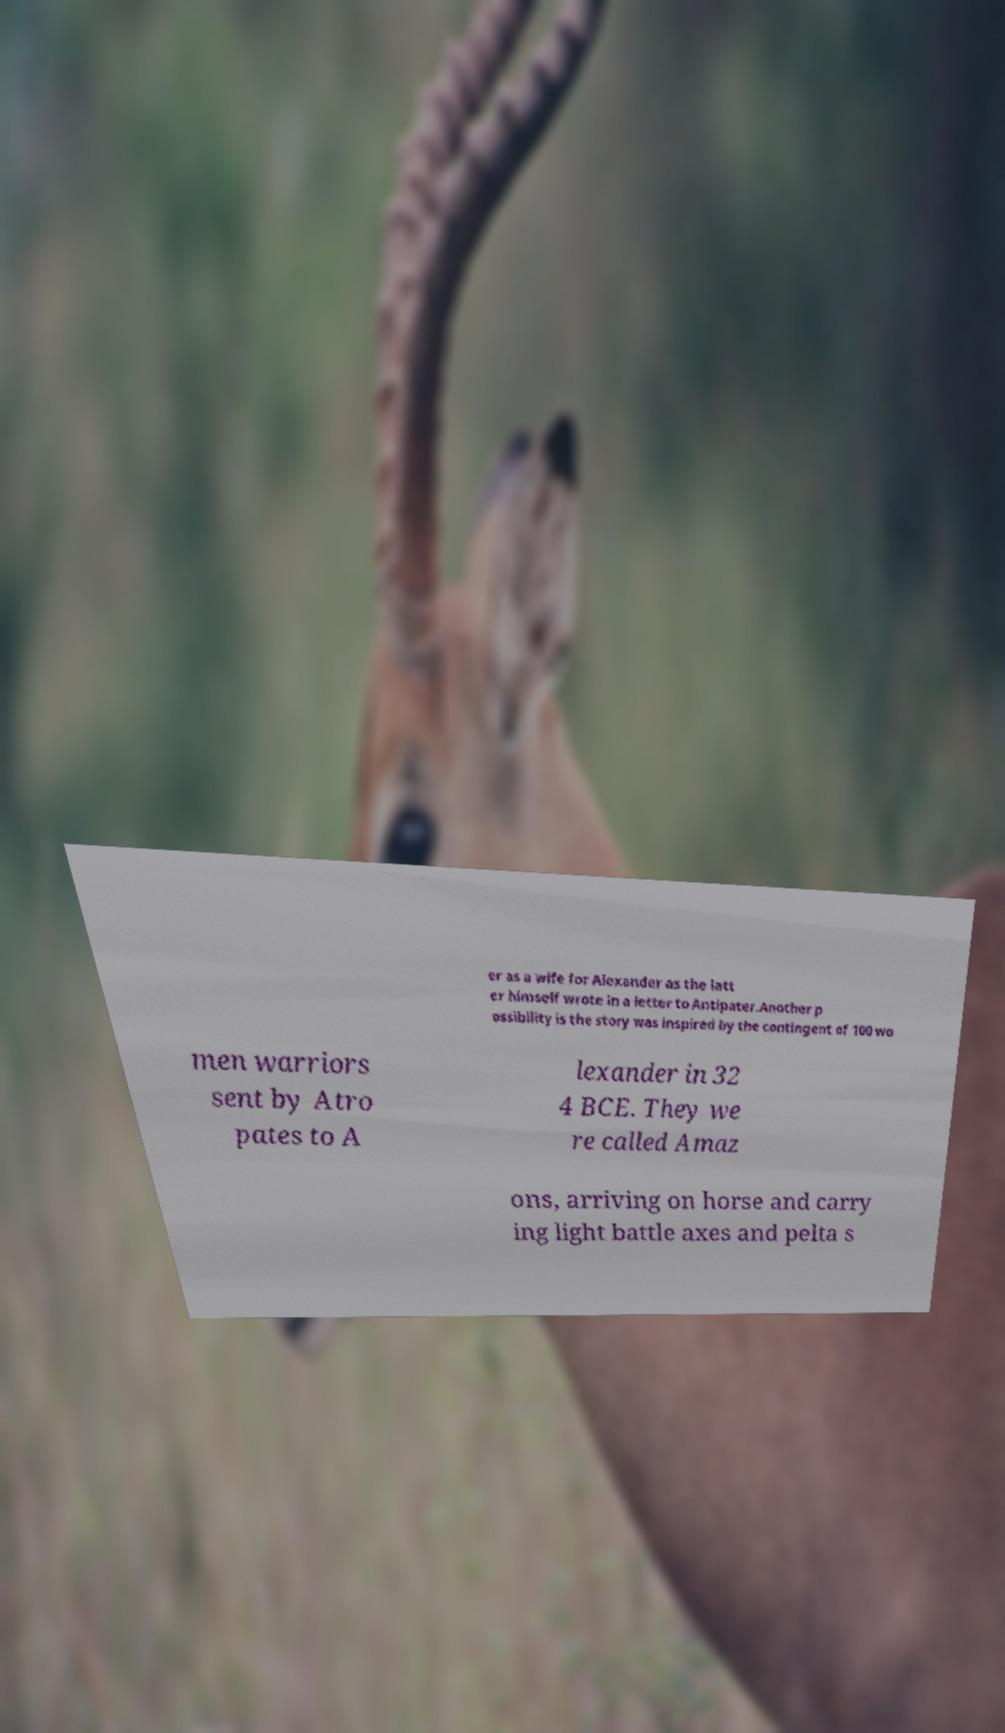Please read and relay the text visible in this image. What does it say? er as a wife for Alexander as the latt er himself wrote in a letter to Antipater.Another p ossibility is the story was inspired by the contingent of 100 wo men warriors sent by Atro pates to A lexander in 32 4 BCE. They we re called Amaz ons, arriving on horse and carry ing light battle axes and pelta s 